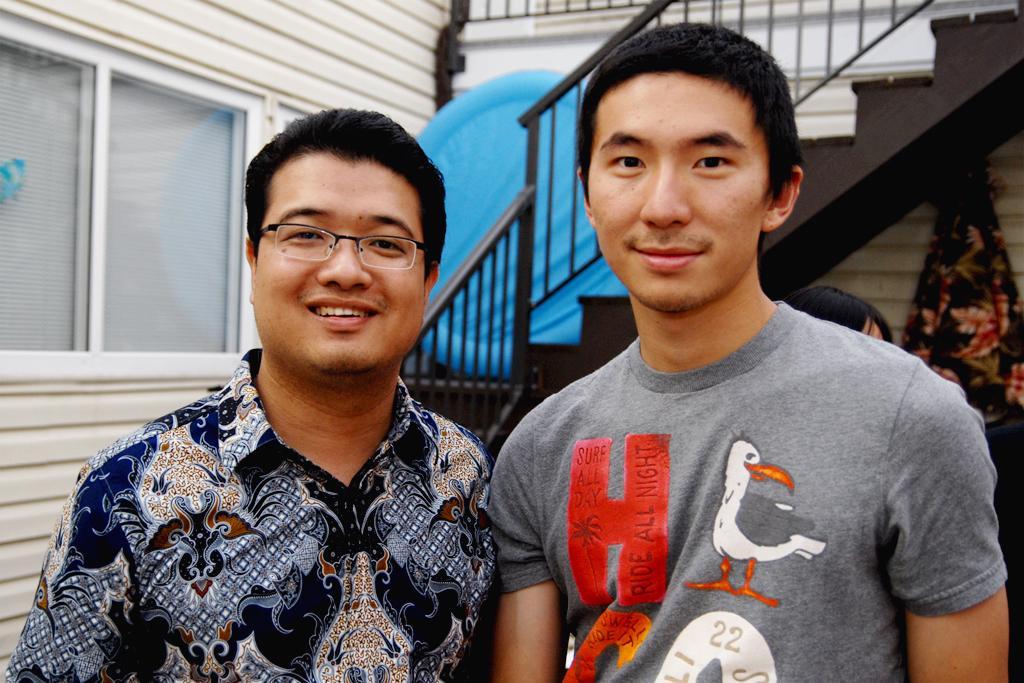Please provide a concise description of this image. In this image we can see some people standing. On the backside we can see a building with windows, a staircase and a cloth. 